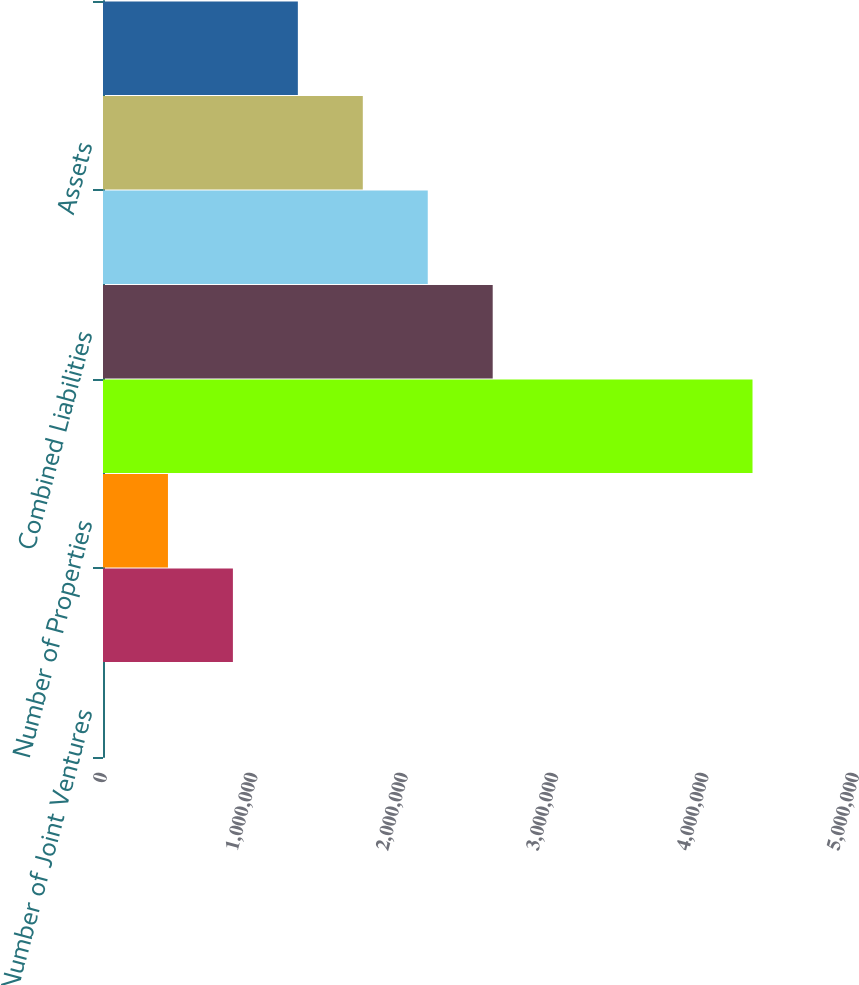Convert chart to OTSL. <chart><loc_0><loc_0><loc_500><loc_500><bar_chart><fcel>Number of Joint Ventures<fcel>Regency's Ownership<fcel>Number of Properties<fcel>Combined Assets<fcel>Combined Liabilities<fcel>Combined Equity<fcel>Assets<fcel>Liabilities<nl><fcel>15<fcel>863728<fcel>431872<fcel>4.31858e+06<fcel>2.59115e+06<fcel>2.1593e+06<fcel>1.72744e+06<fcel>1.29558e+06<nl></chart> 